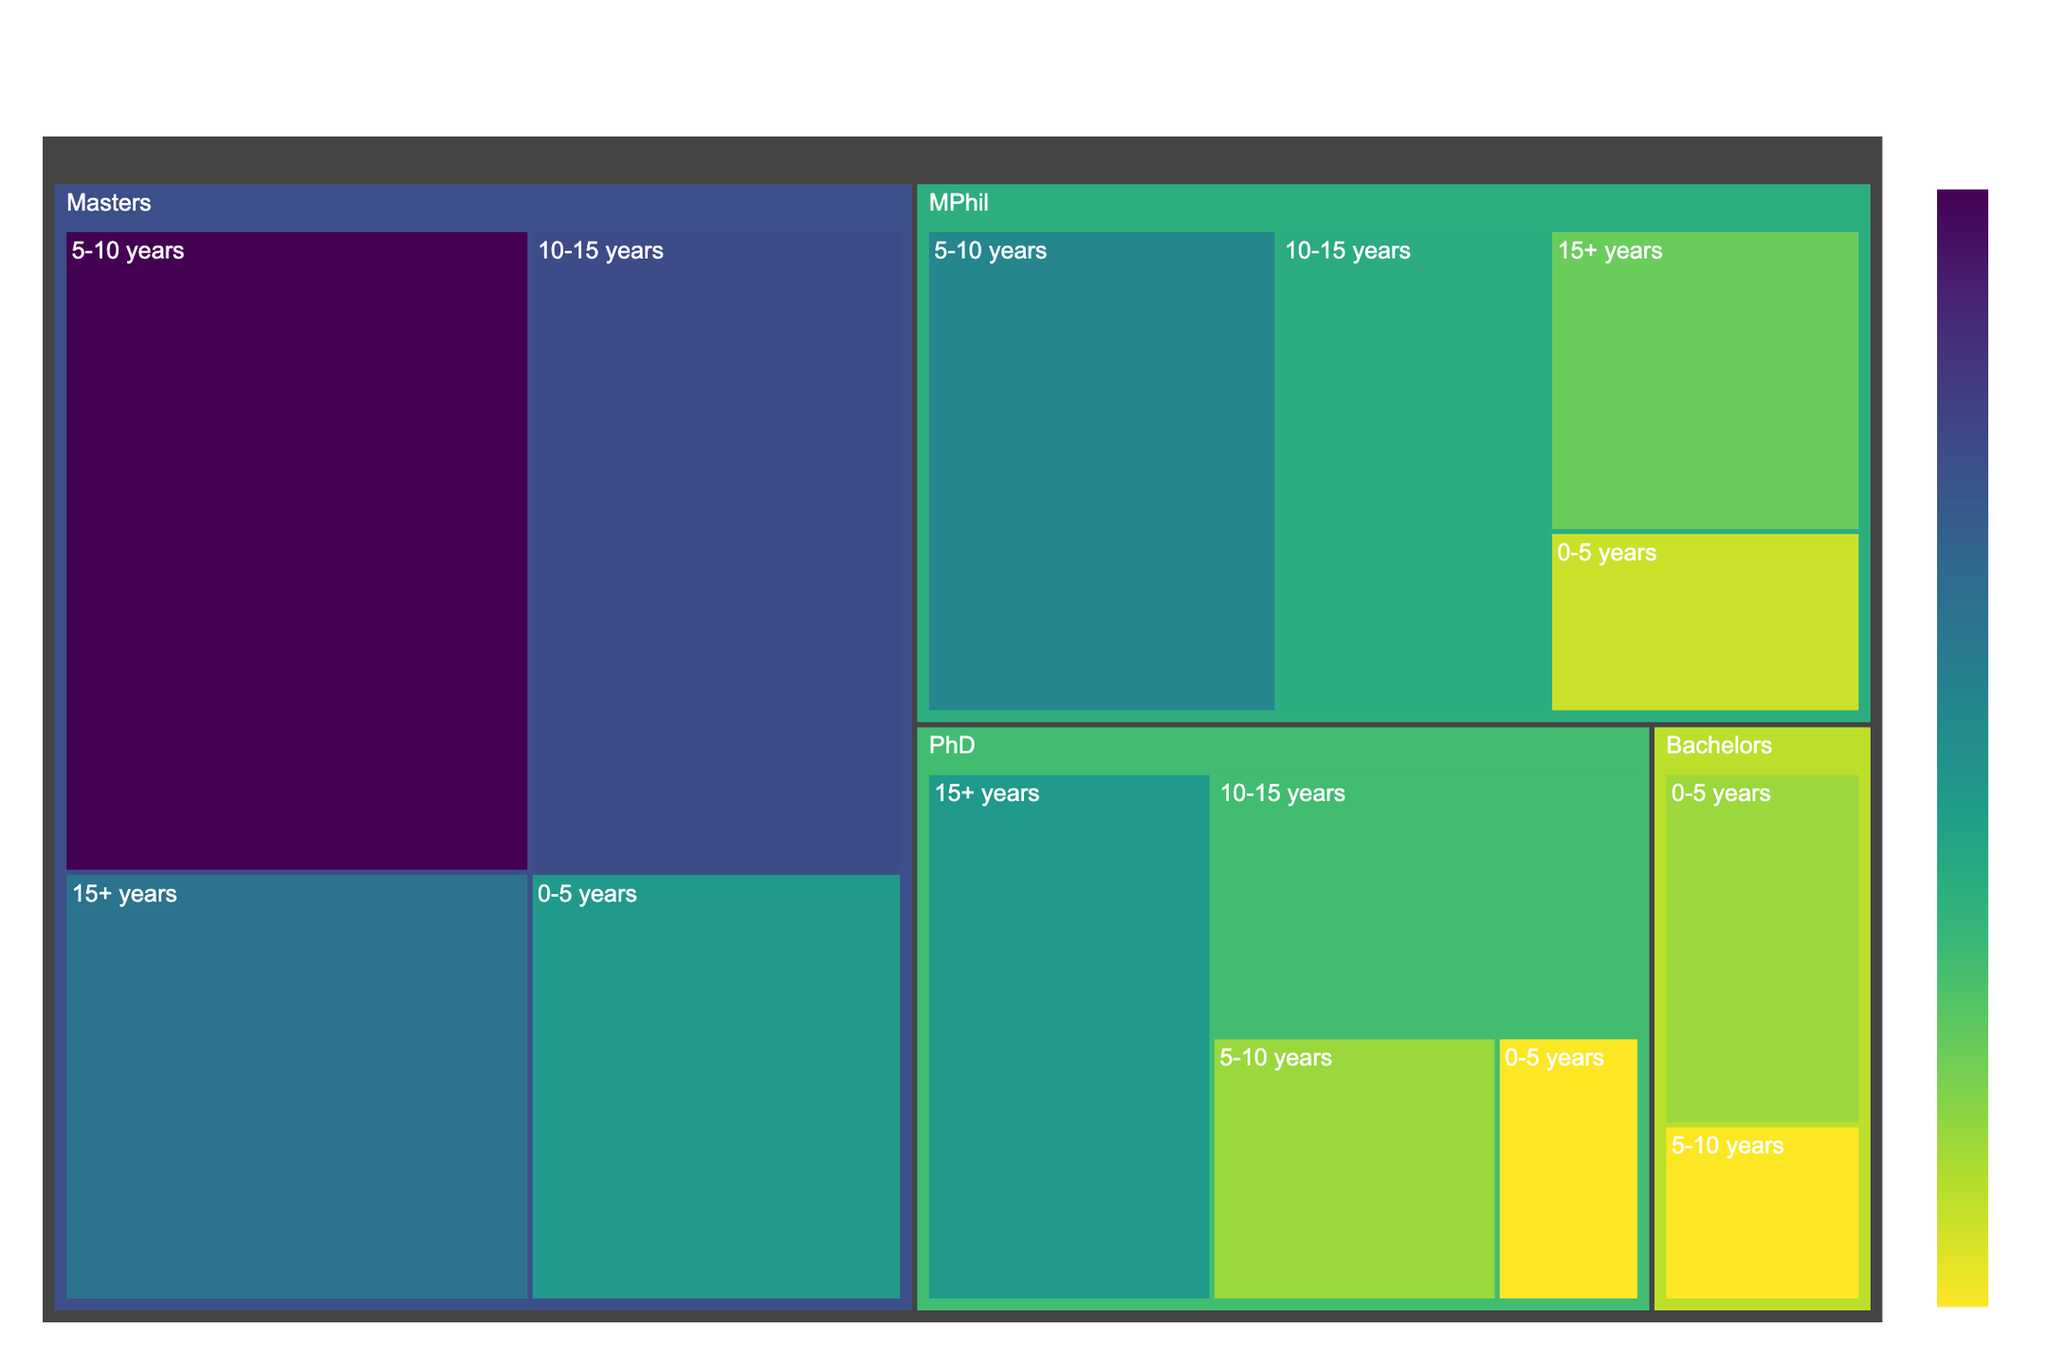What is the title of the treemap? The title is usually positioned at the top center of the plot. In this case, the title should indicate the subject matter of the treemap.
Answer: Faculty Composition by Qualifications and Experience Which qualification has the highest number of faculty members? To determine this, observe the treemap areas for each qualification category. The largest area represents the highest count.
Answer: Masters How many faculty members have a PhD and 15+ years of experience? Navigate to the section labeled "PhD" and then find the sub-section with "15+ years." The value shown there is the count.
Answer: 8 Compare the number of faculty members with MPhil vs. Masters qualifications who have 10-15 years of experience. Look at the respective sections for "MPhil" and "Masters," and then compare the "10-15 years" sub-sections under each qualification.
Answer: 7 (MPhil) vs. 12 (Masters) What is the total number of faculty members with less than 5 years of experience? Sum the counts for "<qualification>, 0-5 years" for all qualifications (PhD, MPhil, Masters, and Bachelors).
Answer: 2 (PhD) + 3 (MPhil) + 8 (Masters) + 4 (Bachelors) = 17 Which experience level has the largest number of faculty members overall? To determine this, add up the counts for each experience level across all qualifications and compare the sums.
Answer: 5-10 years How many PhD-qualified faculty members are there in total? Add the counts for each sub-section under "PhD."
Answer: 8 + 6 + 4 + 2 = 20 Which qualification has the smallest count for the 0-5 years experience category? Navigate to the "0-5 years" sections under each qualification and look for the smallest number.
Answer: PhD Is the number of Bachelors-qualified faculty members with 0-5 years of experience greater than those with 5-10 years of experience? Compare the counts for "Bachelors, 0-5 years" and "Bachelors, 5-10 years."
Answer: Yes (4 vs 2) What is the proportion of Masters-qualified faculty members with 15+ years of experience compared to all Masters-qualified faculty members? Divide the count of "Masters, 15+ years" by the total count for "Masters" and multiply by 100 for the percentage.
Answer: (10 / (10 + 12 + 15 + 8)) * 100 = 20% 